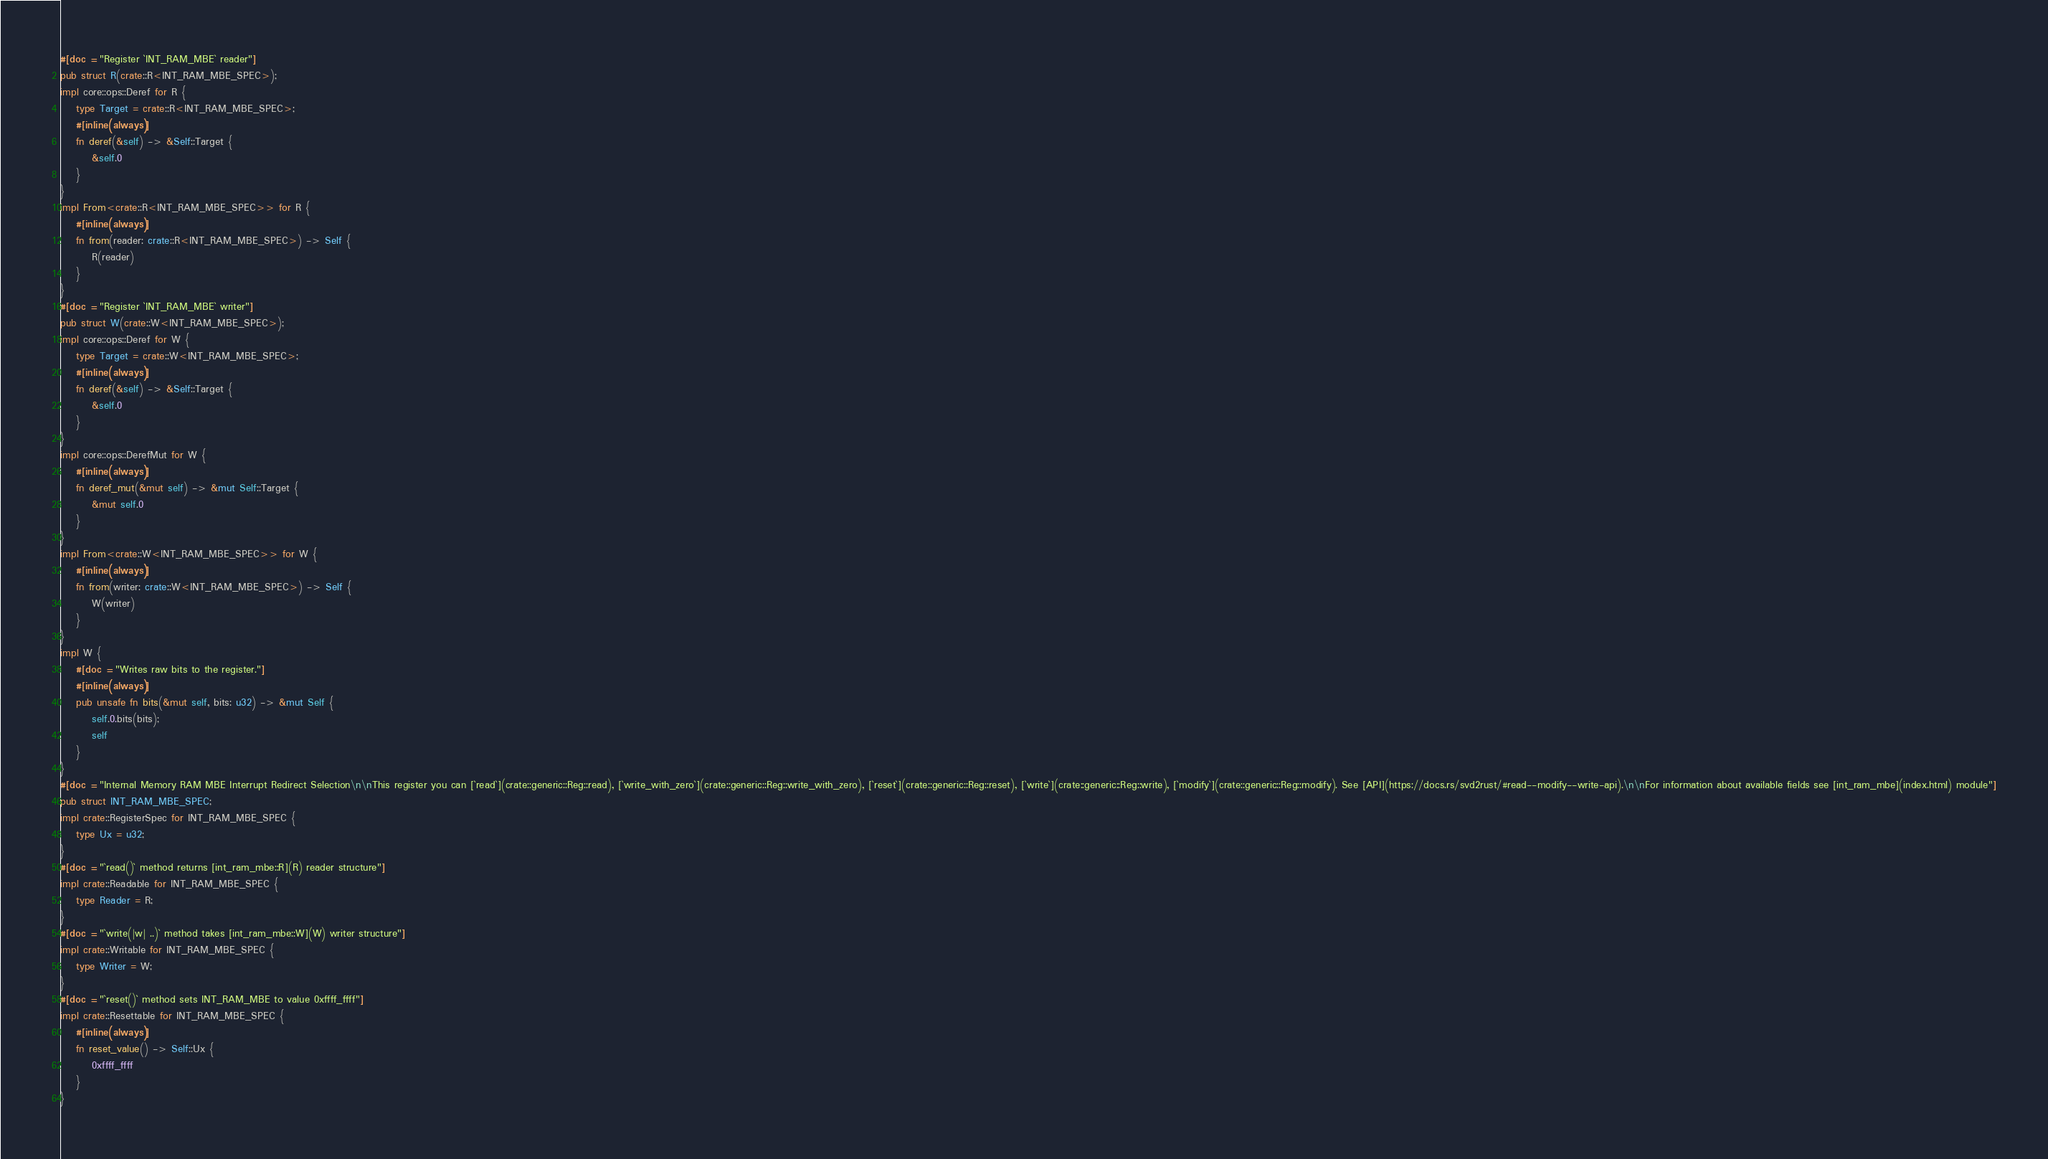Convert code to text. <code><loc_0><loc_0><loc_500><loc_500><_Rust_>#[doc = "Register `INT_RAM_MBE` reader"]
pub struct R(crate::R<INT_RAM_MBE_SPEC>);
impl core::ops::Deref for R {
    type Target = crate::R<INT_RAM_MBE_SPEC>;
    #[inline(always)]
    fn deref(&self) -> &Self::Target {
        &self.0
    }
}
impl From<crate::R<INT_RAM_MBE_SPEC>> for R {
    #[inline(always)]
    fn from(reader: crate::R<INT_RAM_MBE_SPEC>) -> Self {
        R(reader)
    }
}
#[doc = "Register `INT_RAM_MBE` writer"]
pub struct W(crate::W<INT_RAM_MBE_SPEC>);
impl core::ops::Deref for W {
    type Target = crate::W<INT_RAM_MBE_SPEC>;
    #[inline(always)]
    fn deref(&self) -> &Self::Target {
        &self.0
    }
}
impl core::ops::DerefMut for W {
    #[inline(always)]
    fn deref_mut(&mut self) -> &mut Self::Target {
        &mut self.0
    }
}
impl From<crate::W<INT_RAM_MBE_SPEC>> for W {
    #[inline(always)]
    fn from(writer: crate::W<INT_RAM_MBE_SPEC>) -> Self {
        W(writer)
    }
}
impl W {
    #[doc = "Writes raw bits to the register."]
    #[inline(always)]
    pub unsafe fn bits(&mut self, bits: u32) -> &mut Self {
        self.0.bits(bits);
        self
    }
}
#[doc = "Internal Memory RAM MBE Interrupt Redirect Selection\n\nThis register you can [`read`](crate::generic::Reg::read), [`write_with_zero`](crate::generic::Reg::write_with_zero), [`reset`](crate::generic::Reg::reset), [`write`](crate::generic::Reg::write), [`modify`](crate::generic::Reg::modify). See [API](https://docs.rs/svd2rust/#read--modify--write-api).\n\nFor information about available fields see [int_ram_mbe](index.html) module"]
pub struct INT_RAM_MBE_SPEC;
impl crate::RegisterSpec for INT_RAM_MBE_SPEC {
    type Ux = u32;
}
#[doc = "`read()` method returns [int_ram_mbe::R](R) reader structure"]
impl crate::Readable for INT_RAM_MBE_SPEC {
    type Reader = R;
}
#[doc = "`write(|w| ..)` method takes [int_ram_mbe::W](W) writer structure"]
impl crate::Writable for INT_RAM_MBE_SPEC {
    type Writer = W;
}
#[doc = "`reset()` method sets INT_RAM_MBE to value 0xffff_ffff"]
impl crate::Resettable for INT_RAM_MBE_SPEC {
    #[inline(always)]
    fn reset_value() -> Self::Ux {
        0xffff_ffff
    }
}
</code> 